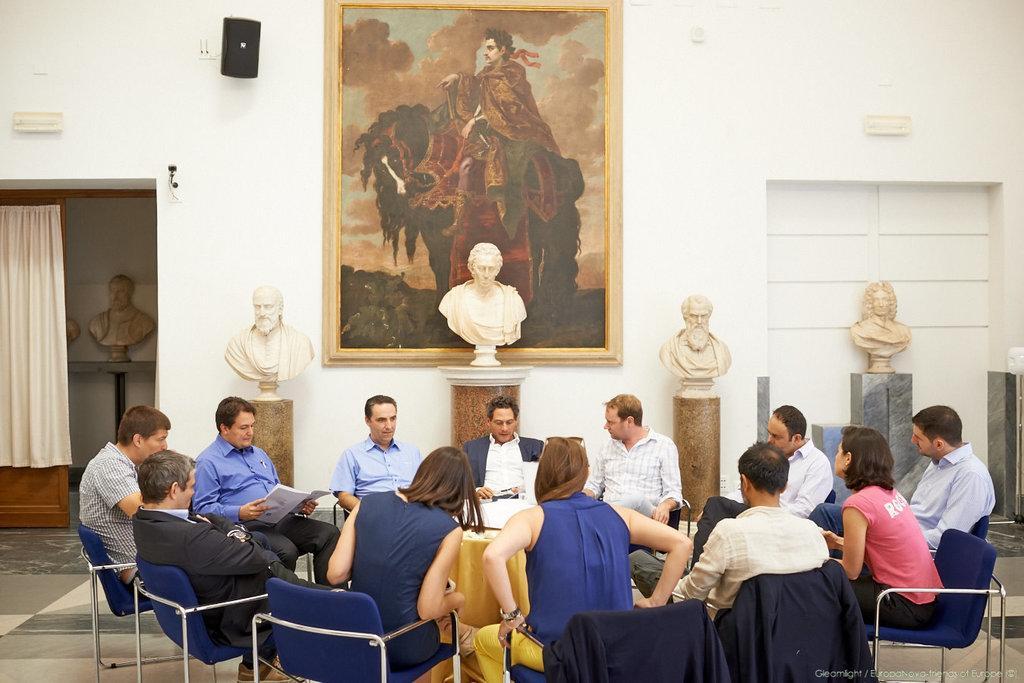Please provide a concise description of this image. In this picture there are several people sitting in a round table. In the background we also many sculptures placed on top of a table, there is also a painting back of it. 